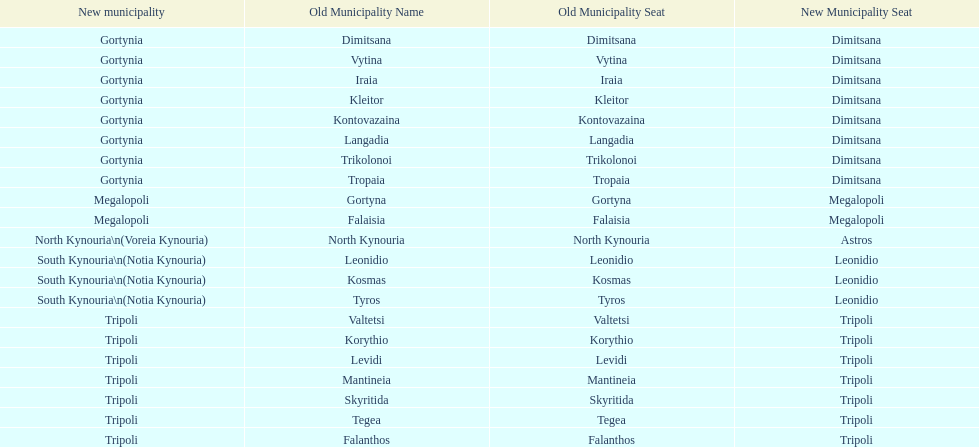Is tripoli still considered a municipality in arcadia since its 2011 reformation? Yes. 